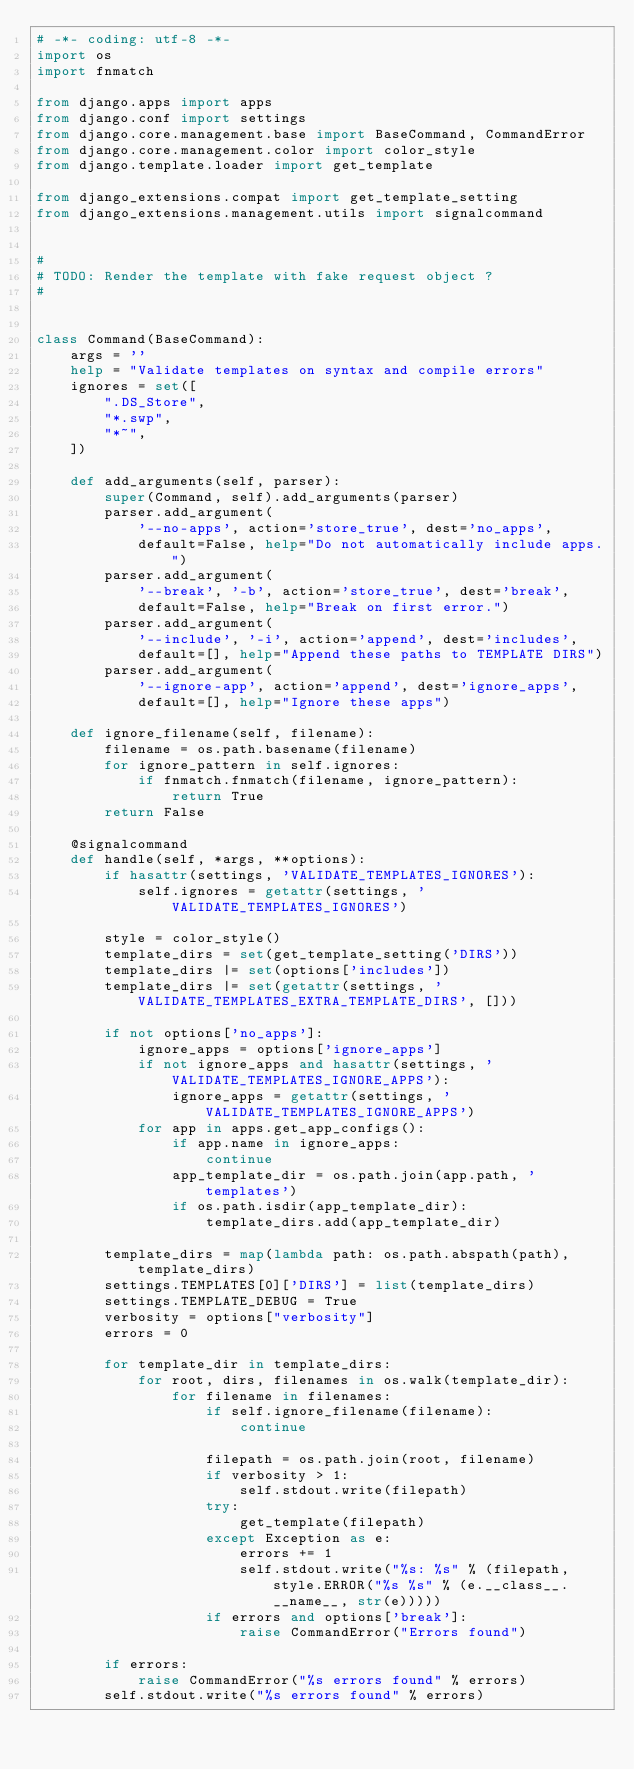Convert code to text. <code><loc_0><loc_0><loc_500><loc_500><_Python_># -*- coding: utf-8 -*-
import os
import fnmatch

from django.apps import apps
from django.conf import settings
from django.core.management.base import BaseCommand, CommandError
from django.core.management.color import color_style
from django.template.loader import get_template

from django_extensions.compat import get_template_setting
from django_extensions.management.utils import signalcommand


#
# TODO: Render the template with fake request object ?
#


class Command(BaseCommand):
    args = ''
    help = "Validate templates on syntax and compile errors"
    ignores = set([
        ".DS_Store",
        "*.swp",
        "*~",
    ])

    def add_arguments(self, parser):
        super(Command, self).add_arguments(parser)
        parser.add_argument(
            '--no-apps', action='store_true', dest='no_apps',
            default=False, help="Do not automatically include apps.")
        parser.add_argument(
            '--break', '-b', action='store_true', dest='break',
            default=False, help="Break on first error.")
        parser.add_argument(
            '--include', '-i', action='append', dest='includes',
            default=[], help="Append these paths to TEMPLATE DIRS")
        parser.add_argument(
            '--ignore-app', action='append', dest='ignore_apps',
            default=[], help="Ignore these apps")

    def ignore_filename(self, filename):
        filename = os.path.basename(filename)
        for ignore_pattern in self.ignores:
            if fnmatch.fnmatch(filename, ignore_pattern):
                return True
        return False

    @signalcommand
    def handle(self, *args, **options):
        if hasattr(settings, 'VALIDATE_TEMPLATES_IGNORES'):
            self.ignores = getattr(settings, 'VALIDATE_TEMPLATES_IGNORES')

        style = color_style()
        template_dirs = set(get_template_setting('DIRS'))
        template_dirs |= set(options['includes'])
        template_dirs |= set(getattr(settings, 'VALIDATE_TEMPLATES_EXTRA_TEMPLATE_DIRS', []))

        if not options['no_apps']:
            ignore_apps = options['ignore_apps']
            if not ignore_apps and hasattr(settings, 'VALIDATE_TEMPLATES_IGNORE_APPS'):
                ignore_apps = getattr(settings, 'VALIDATE_TEMPLATES_IGNORE_APPS')
            for app in apps.get_app_configs():
                if app.name in ignore_apps:
                    continue
                app_template_dir = os.path.join(app.path, 'templates')
                if os.path.isdir(app_template_dir):
                    template_dirs.add(app_template_dir)

        template_dirs = map(lambda path: os.path.abspath(path), template_dirs)
        settings.TEMPLATES[0]['DIRS'] = list(template_dirs)
        settings.TEMPLATE_DEBUG = True
        verbosity = options["verbosity"]
        errors = 0

        for template_dir in template_dirs:
            for root, dirs, filenames in os.walk(template_dir):
                for filename in filenames:
                    if self.ignore_filename(filename):
                        continue

                    filepath = os.path.join(root, filename)
                    if verbosity > 1:
                        self.stdout.write(filepath)
                    try:
                        get_template(filepath)
                    except Exception as e:
                        errors += 1
                        self.stdout.write("%s: %s" % (filepath, style.ERROR("%s %s" % (e.__class__.__name__, str(e)))))
                    if errors and options['break']:
                        raise CommandError("Errors found")

        if errors:
            raise CommandError("%s errors found" % errors)
        self.stdout.write("%s errors found" % errors)
</code> 